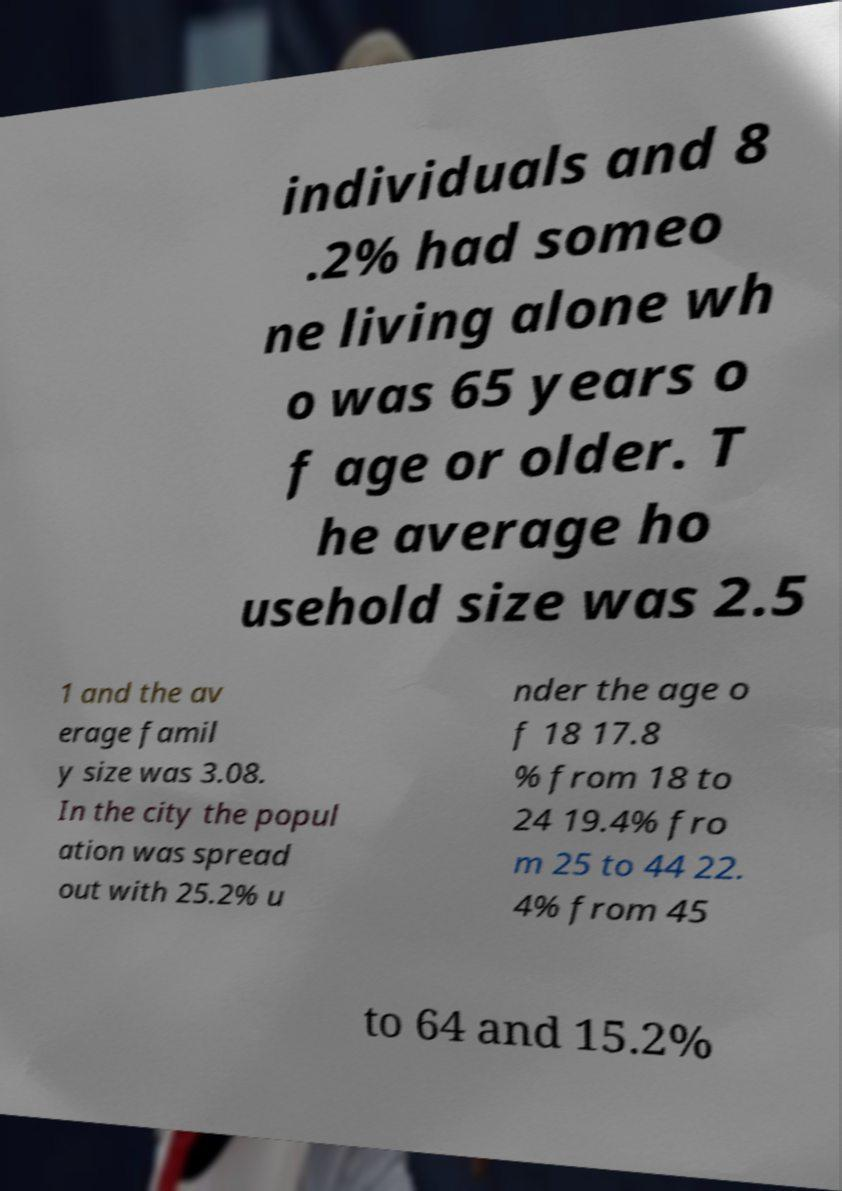What messages or text are displayed in this image? I need them in a readable, typed format. individuals and 8 .2% had someo ne living alone wh o was 65 years o f age or older. T he average ho usehold size was 2.5 1 and the av erage famil y size was 3.08. In the city the popul ation was spread out with 25.2% u nder the age o f 18 17.8 % from 18 to 24 19.4% fro m 25 to 44 22. 4% from 45 to 64 and 15.2% 